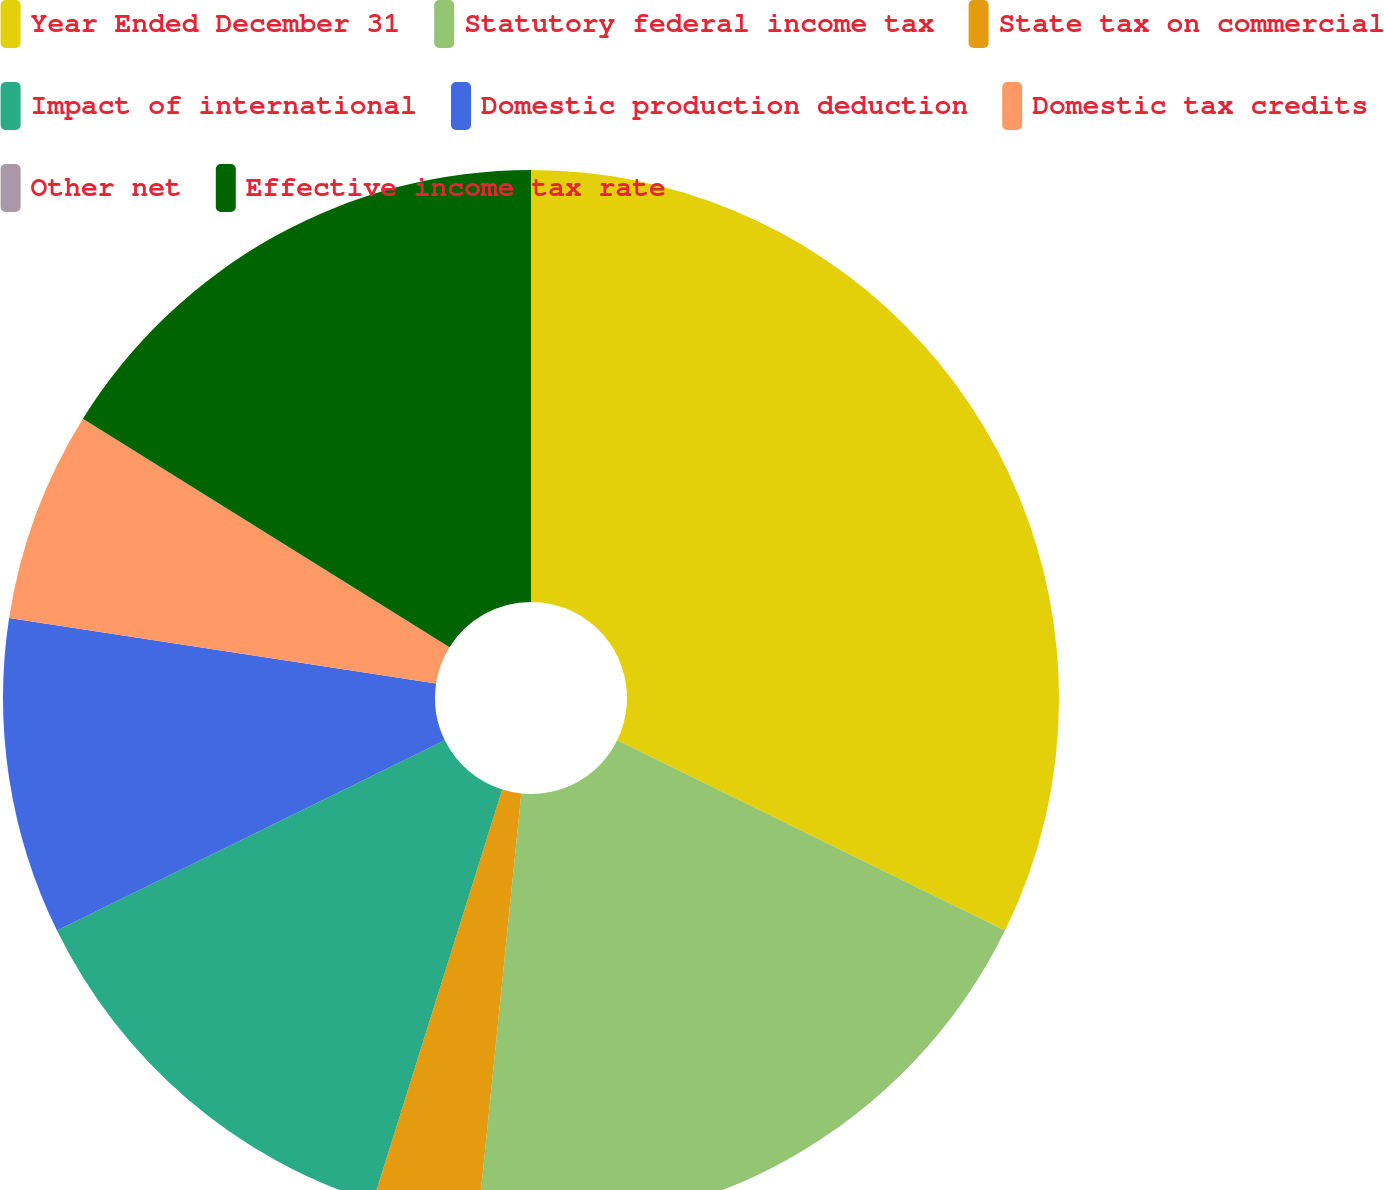Convert chart to OTSL. <chart><loc_0><loc_0><loc_500><loc_500><pie_chart><fcel>Year Ended December 31<fcel>Statutory federal income tax<fcel>State tax on commercial<fcel>Impact of international<fcel>Domestic production deduction<fcel>Domestic tax credits<fcel>Other net<fcel>Effective income tax rate<nl><fcel>32.26%<fcel>19.35%<fcel>3.23%<fcel>12.9%<fcel>9.68%<fcel>6.45%<fcel>0.0%<fcel>16.13%<nl></chart> 